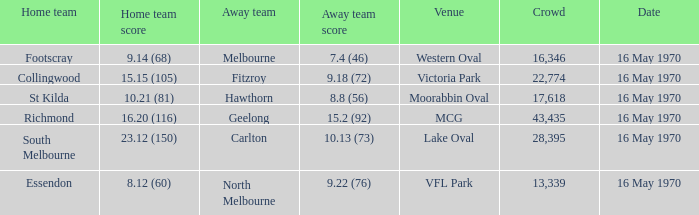What guest team achieved Fitzroy. 